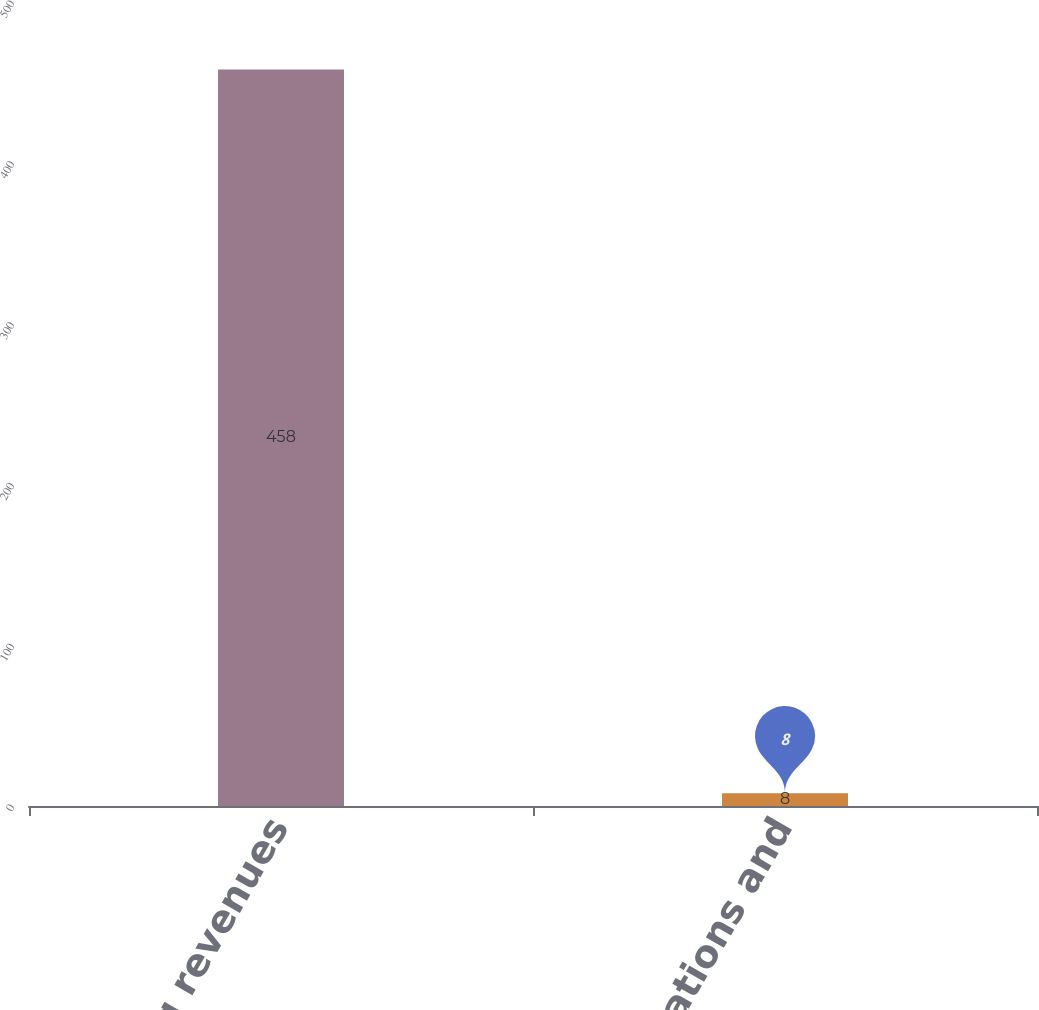Convert chart. <chart><loc_0><loc_0><loc_500><loc_500><bar_chart><fcel>Operating revenues<fcel>Other operations and<nl><fcel>458<fcel>8<nl></chart> 